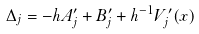<formula> <loc_0><loc_0><loc_500><loc_500>\Delta _ { j } = - h A _ { j } ^ { \prime } + B _ { j } ^ { \prime } + h ^ { - 1 } V _ { j } ^ { \prime } ( x )</formula> 